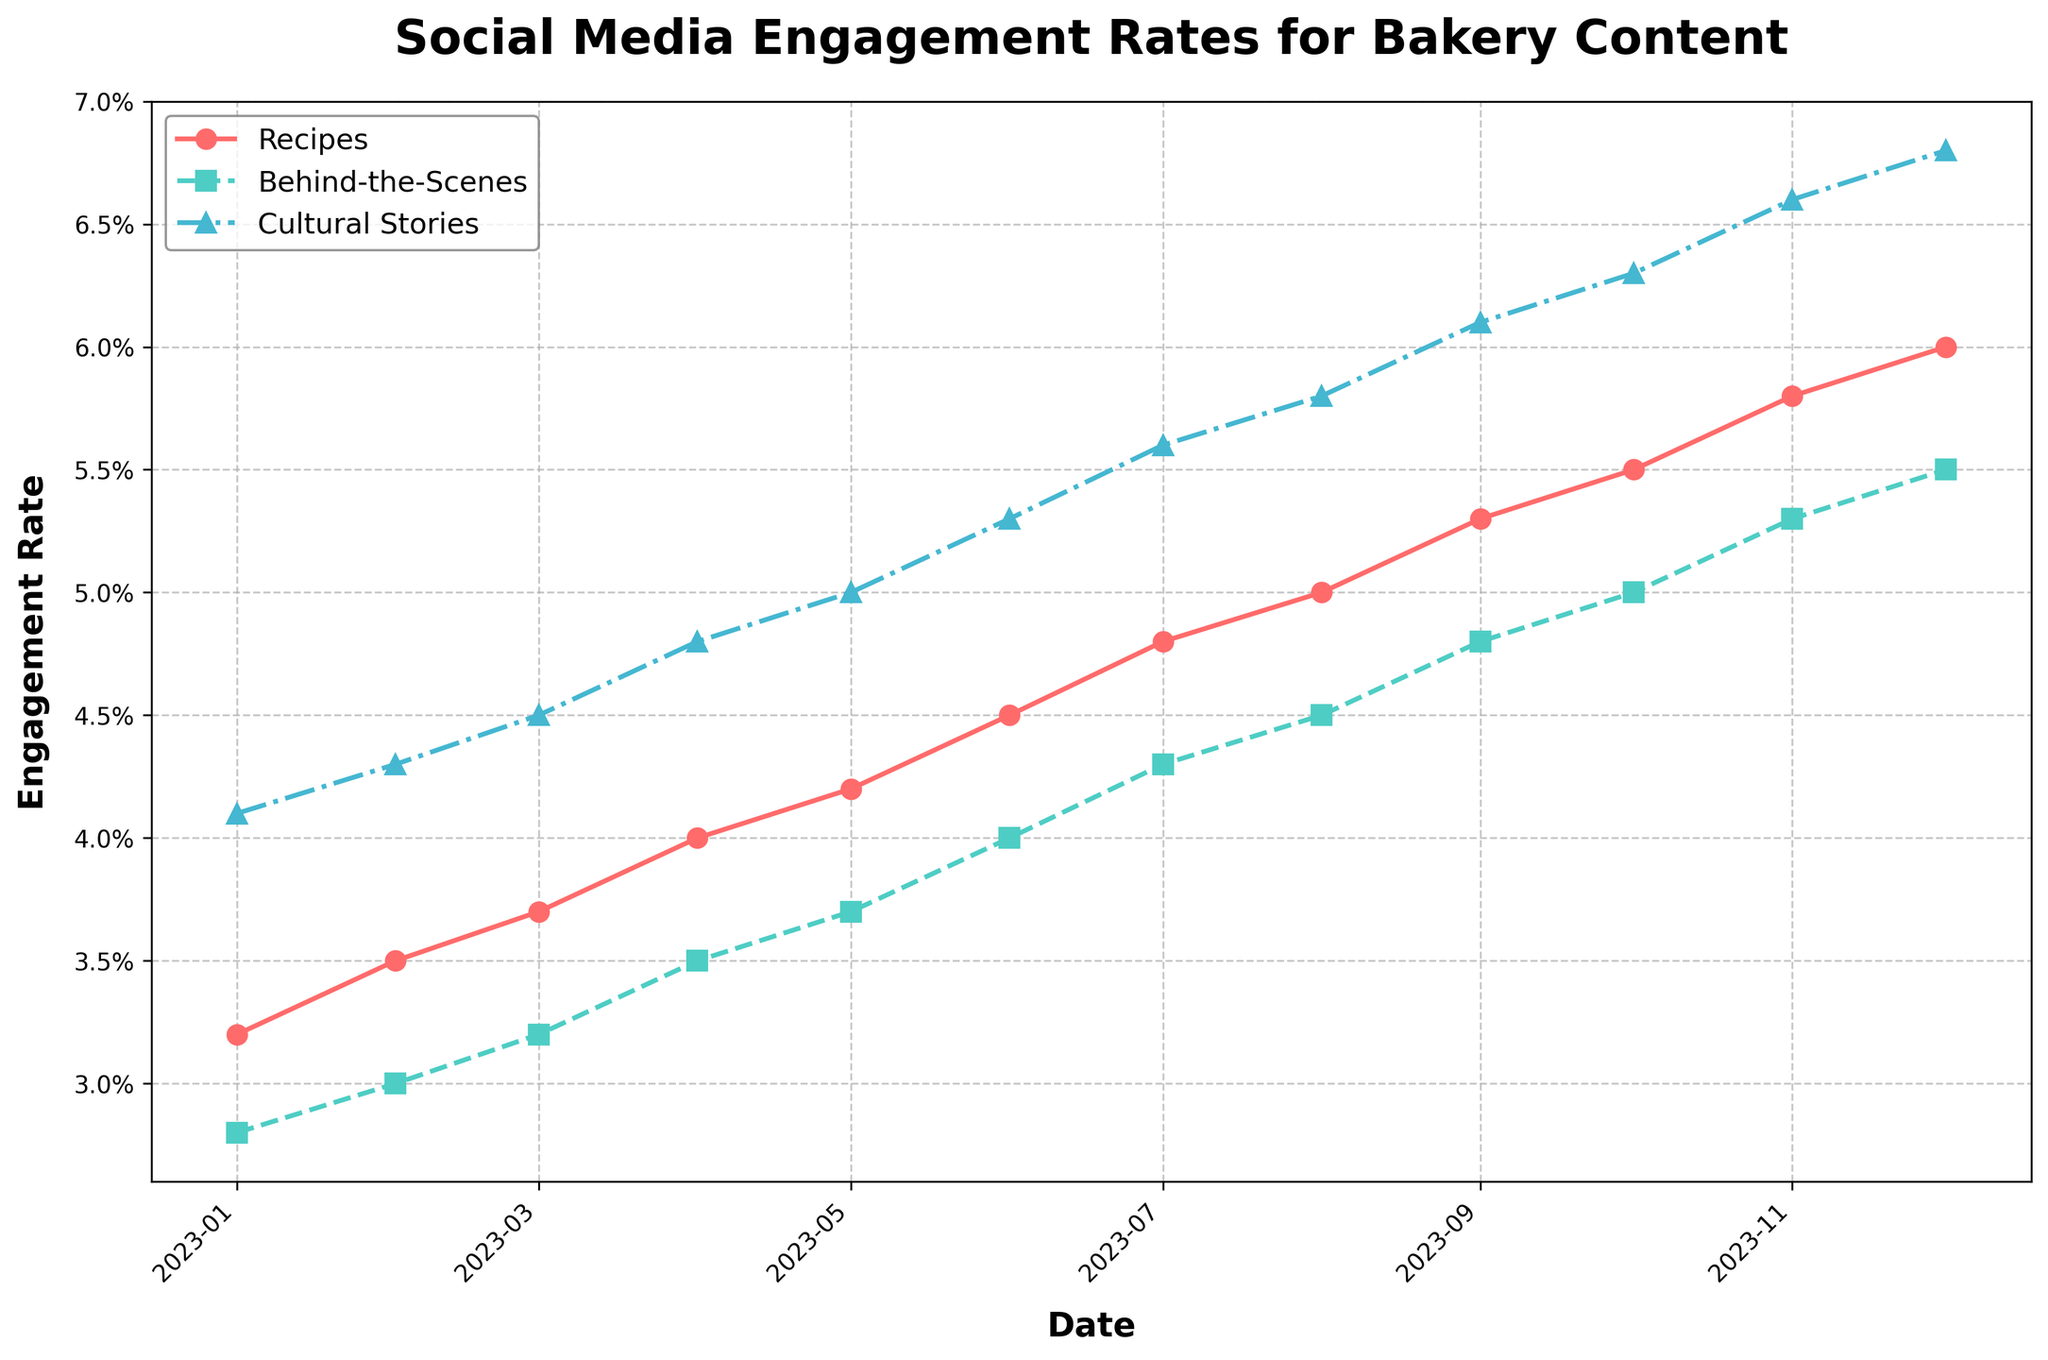What's the average engagement rate for the 'Cultural Stories' content over the year? Sum all the engagement rates for 'Cultural Stories' and divide by the number of data points. (4.1% + 4.3% + 4.5% + 4.8% + 5.0% + 5.3% + 5.6% + 5.8% + 6.1% + 6.3% + 6.6% + 6.8%) = 65.3%. Divide by 12 to get the average: 65.3% / 12 ≈ 5.44%.
Answer: 5.44% Which type of content had the highest engagement rate in December 2023? Look at the engagement rates for all three types of content in December 2023. 'Recipes' had 6.0%, 'Behind-the-Scenes' had 5.5%, and 'Cultural Stories' had 6.8%. The highest is for 'Cultural Stories'.
Answer: Cultural Stories Has the 'Behind-the-Scenes' content consistently shown an increase in engagement rate over the year? Observe the trend for 'Behind-the-Scenes' over the months. The engagement rate goes from 2.8% in January to 5.5% in December. It consistently increases each month without any drop.
Answer: Yes Is the engagement rate for 'Recipes' ever equal to that of 'Cultural Stories'? Compare the monthly engagement rates of 'Recipes' and 'Cultural Stories'. At no point do they have the same percentage. The 'Cultural Stories' consistently have higher engagement rates than 'Recipes'.
Answer: No What is the difference in engagement rate between 'Recipes' and 'Behind-the-Scenes' in October 2023? Look at the engagement rates for both types of content in October 2023. 'Recipes' = 5.5% and 'Behind-the-Scenes' = 5.0%. The difference is 5.5% - 5.0% = 0.5%.
Answer: 0.5% Which month saw the largest increase in engagement rate for 'Cultural Stories' compared to the previous month? Compare the monthly increases for 'Cultural Stories': 4.1% to 4.3% (0.2%), 4.3% to 4.5% (0.2%), 4.5% to 4.8% (0.3%), 4.8% to 5.0% (0.2%), 5.0% to 5.3% (0.3%), 5.3% to 5.6% (0.3%), 5.6% to 5.8% (0.2%), 5.8% to 6.1% (0.3%), 6.1% to 6.3% (0.2%), 6.3% to 6.6% (0.3%), 6.6% to 6.8% (0.2%). The largest increase (0.3%) occurs in April, July, September, and November.
Answer: April, July, September, November Is there a month where 'Behind-the-Scenes' engagement rate overtakes 'Recipes'? Review the engagement rates for 'Recipes' and 'Behind-the-Scenes' each month. 'Recipes' consistently have higher engagement rates than 'Behind-the-Scenes', so it never overtakes.
Answer: No What is the trend in engagement rates for 'Recipes' from January to December 2023? Observe the monthly engagement rates for 'Recipes'. They start at 3.2% in January and steadily increase to 6.0% in December, showing a positive, consistent upward trend.
Answer: Increasing trend Between which months did the 'Behind-the-Scenes' content see a growth of exactly 0.5% in engagement rate? Look for the months where the difference in 'Behind-the-Scenes' engagement rates is 0.5%: July 4.3% to August 4.5% (0.2%), February 3.0% to March 3.2% (0.2%), October 5.0% to November 5.3% (0.3%), and September 4.8% to October 5.0% are not exact matches. Look at March 3.2% to April 3.5% (0.3%). None shows an exact 0.5% increase in 'Behind-the-Scenes' content engagement.
Answer: None 